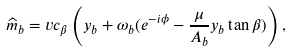Convert formula to latex. <formula><loc_0><loc_0><loc_500><loc_500>\widehat { m } _ { b } = v c _ { \beta } \left ( y _ { b } + \omega _ { b } ( e ^ { - i \phi } - \frac { \mu } { A _ { b } } y _ { b } \tan \beta ) \right ) ,</formula> 